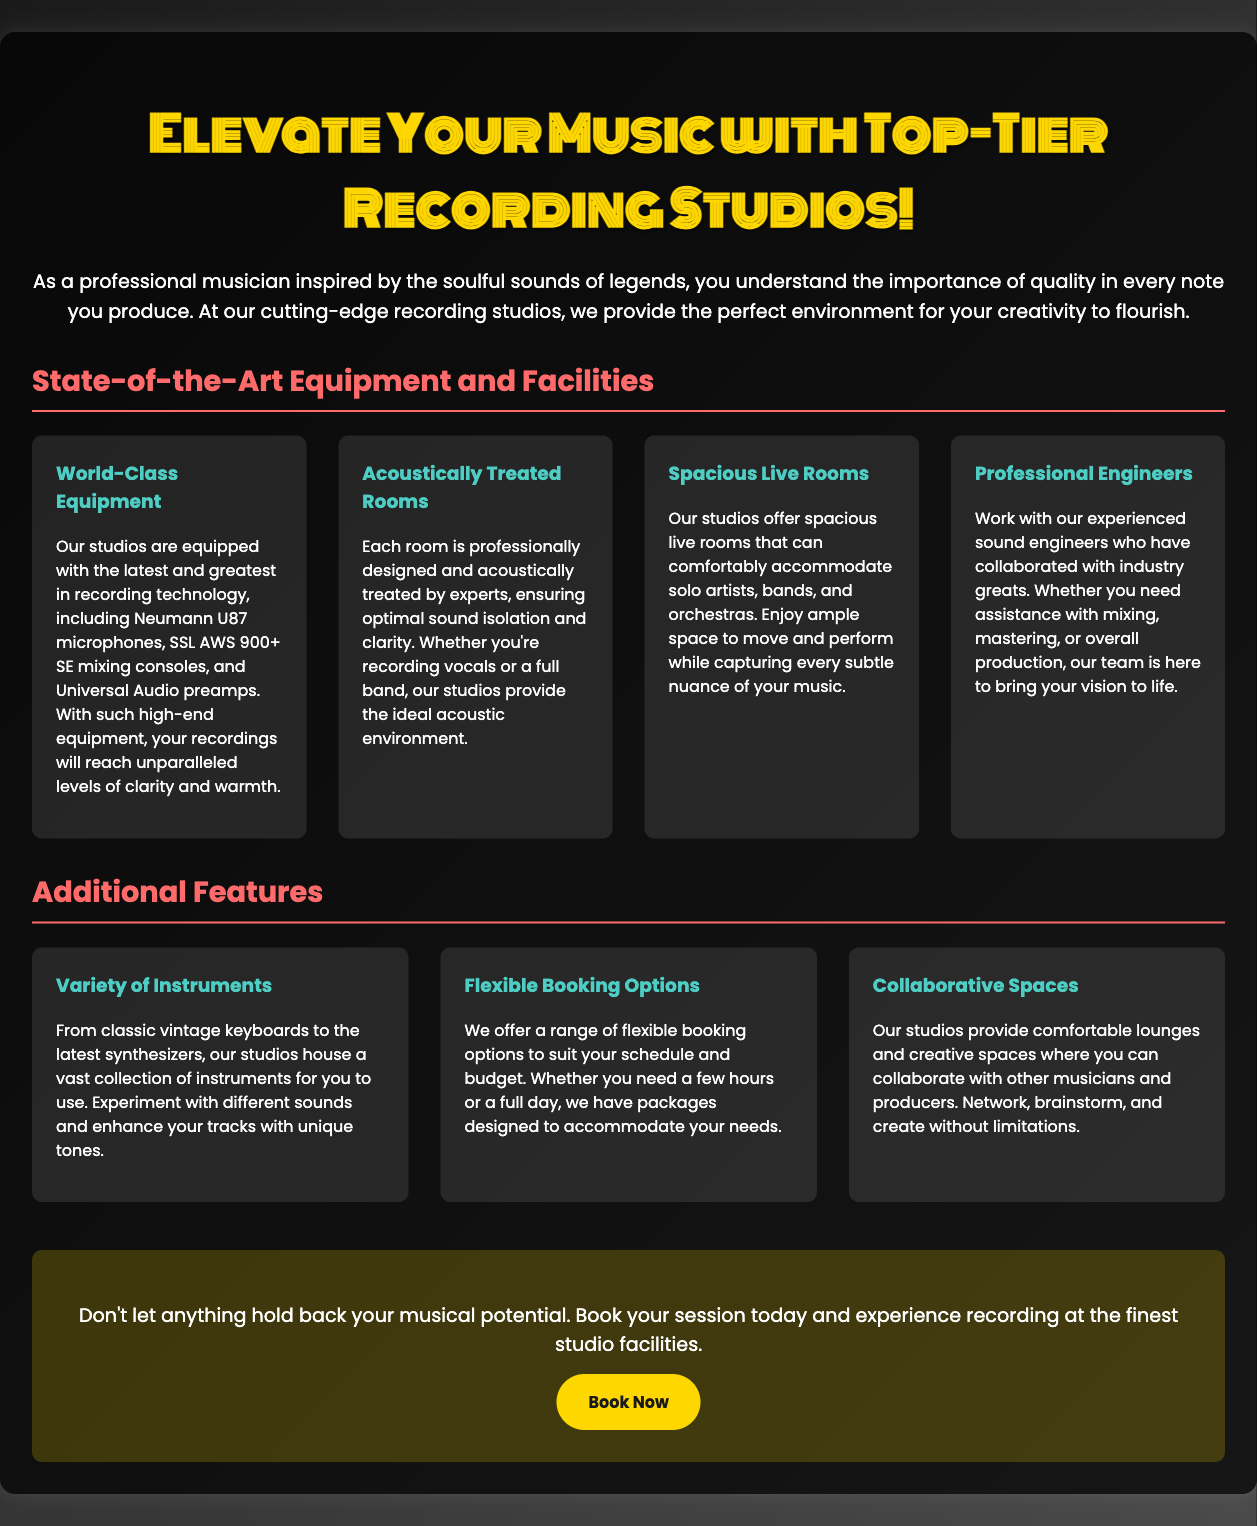What microphones are mentioned? The advertisement highlights Neumann U87 microphones as part of the studio's equipment.
Answer: Neumann U87 What type of mixing console is available? The document states that SSL AWS 900+ SE mixing consoles are part of the studio's equipment.
Answer: SSL AWS 900+ SE What additional feature is offered for convenience? The advertisement mentions flexible booking options as a convenience for clients.
Answer: Flexible booking options How many features are listed in the 'Additional Features' section? There are three features listed in the 'Additional Features' section of the document.
Answer: Three What is the main purpose of the advertisement? The main purpose of the advertisement is to attract musicians to book studio sessions to enhance their recording experience.
Answer: Attract musicians Who can musicians collaborate with at the studio? The studio provides spaces for collaboration with other musicians and producers.
Answer: Other musicians and producers What do the professional engineers assist with? The engineers help with mixing, mastering, or overall production of music.
Answer: Mixing, mastering, or overall production What is emphasized as crucial for recording quality? The document emphasizes the importance of state-of-the-art equipment and acoustically treated rooms for recording quality.
Answer: State-of-the-art equipment and acoustically treated rooms 